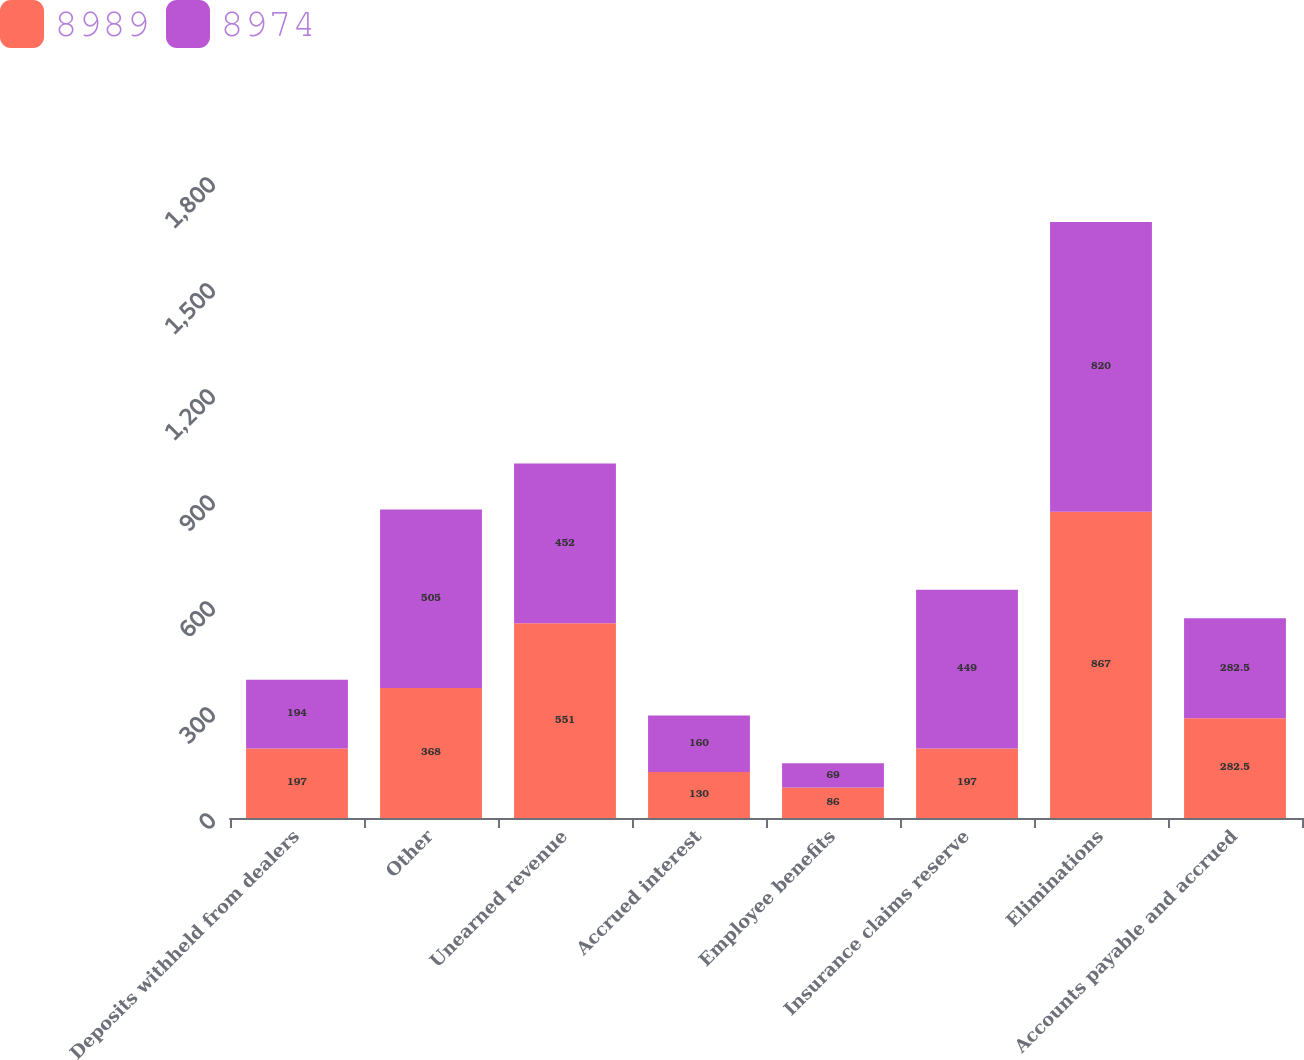Convert chart to OTSL. <chart><loc_0><loc_0><loc_500><loc_500><stacked_bar_chart><ecel><fcel>Deposits withheld from dealers<fcel>Other<fcel>Unearned revenue<fcel>Accrued interest<fcel>Employee benefits<fcel>Insurance claims reserve<fcel>Eliminations<fcel>Accounts payable and accrued<nl><fcel>8989<fcel>197<fcel>368<fcel>551<fcel>130<fcel>86<fcel>197<fcel>867<fcel>282.5<nl><fcel>8974<fcel>194<fcel>505<fcel>452<fcel>160<fcel>69<fcel>449<fcel>820<fcel>282.5<nl></chart> 